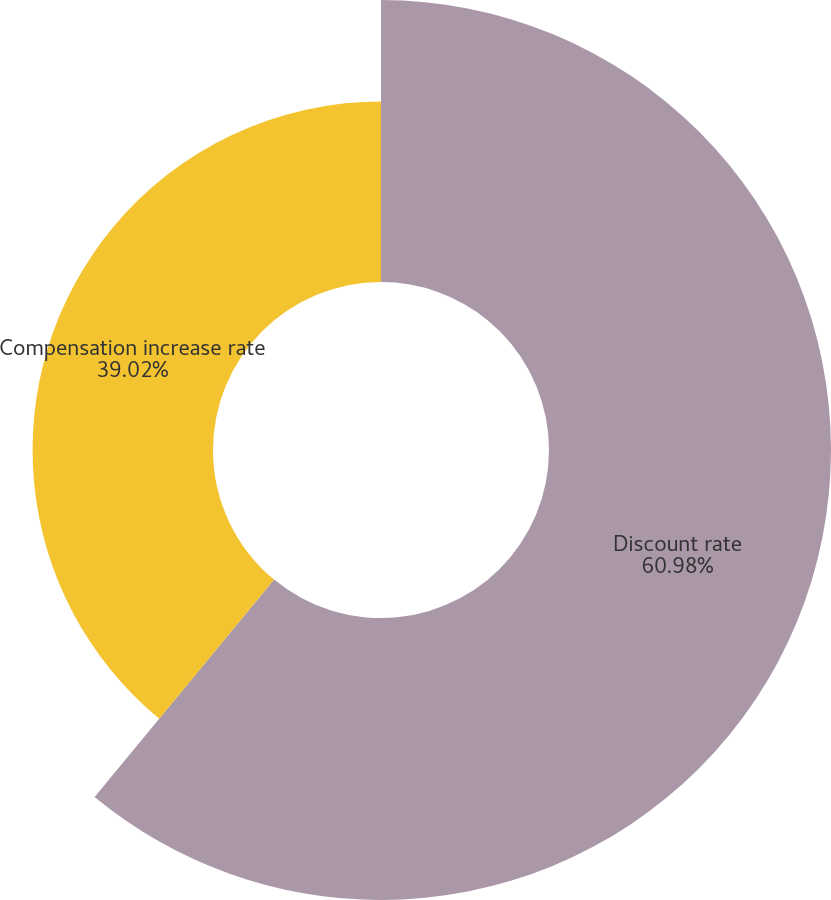Convert chart to OTSL. <chart><loc_0><loc_0><loc_500><loc_500><pie_chart><fcel>Discount rate<fcel>Compensation increase rate<nl><fcel>60.98%<fcel>39.02%<nl></chart> 